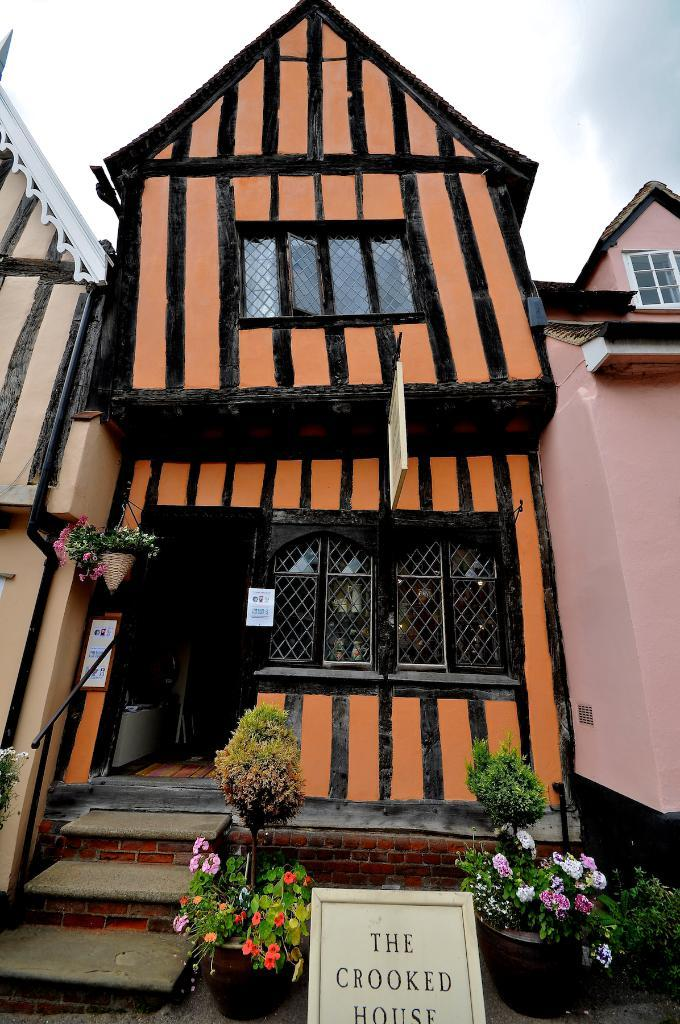What is the main subject of the image? The main subject of the image is a house. What colors are used to paint the house? The house is in orange and black color. Are there any plants visible in the image? Yes, there are flower plants in front of the house. What type of reaction can be seen from the part of the house that is stitched together? There is no part of the house that is stitched together, and therefore no reaction can be observed. 